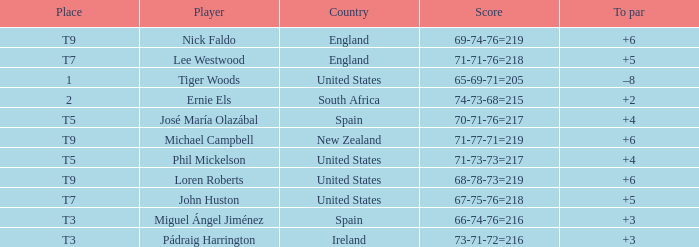What is Player, when Score is "66-74-76=216"? Miguel Ángel Jiménez. 